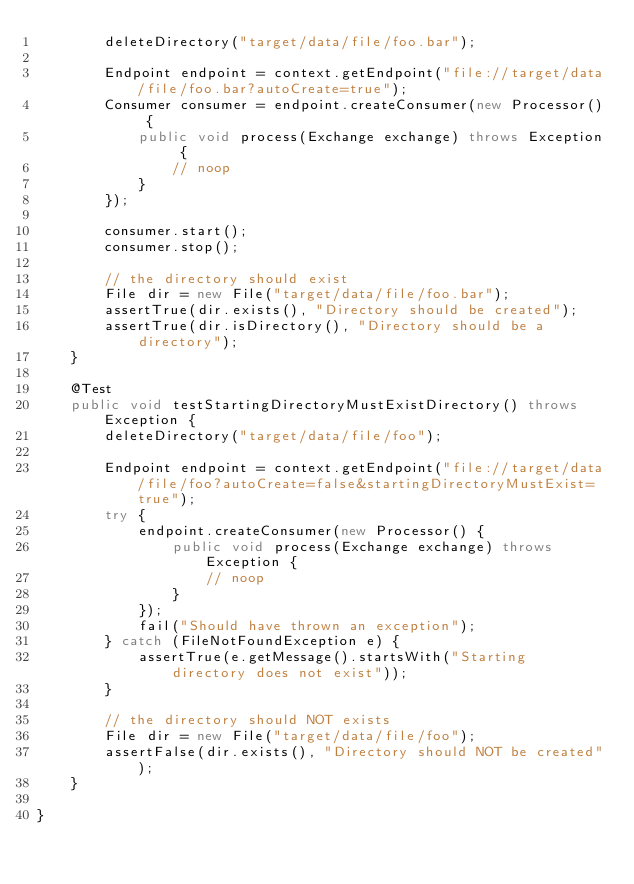<code> <loc_0><loc_0><loc_500><loc_500><_Java_>        deleteDirectory("target/data/file/foo.bar");

        Endpoint endpoint = context.getEndpoint("file://target/data/file/foo.bar?autoCreate=true");
        Consumer consumer = endpoint.createConsumer(new Processor() {
            public void process(Exchange exchange) throws Exception {
                // noop
            }
        });

        consumer.start();
        consumer.stop();

        // the directory should exist
        File dir = new File("target/data/file/foo.bar");
        assertTrue(dir.exists(), "Directory should be created");
        assertTrue(dir.isDirectory(), "Directory should be a directory");
    }

    @Test
    public void testStartingDirectoryMustExistDirectory() throws Exception {
        deleteDirectory("target/data/file/foo");

        Endpoint endpoint = context.getEndpoint("file://target/data/file/foo?autoCreate=false&startingDirectoryMustExist=true");
        try {
            endpoint.createConsumer(new Processor() {
                public void process(Exchange exchange) throws Exception {
                    // noop
                }
            });
            fail("Should have thrown an exception");
        } catch (FileNotFoundException e) {
            assertTrue(e.getMessage().startsWith("Starting directory does not exist"));
        }

        // the directory should NOT exists
        File dir = new File("target/data/file/foo");
        assertFalse(dir.exists(), "Directory should NOT be created");
    }

}
</code> 